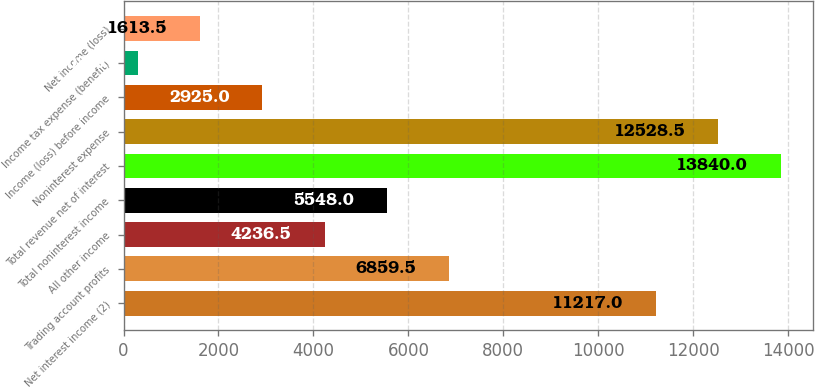Convert chart to OTSL. <chart><loc_0><loc_0><loc_500><loc_500><bar_chart><fcel>Net interest income (2)<fcel>Trading account profits<fcel>All other income<fcel>Total noninterest income<fcel>Total revenue net of interest<fcel>Noninterest expense<fcel>Income (loss) before income<fcel>Income tax expense (benefit)<fcel>Net income (loss)<nl><fcel>11217<fcel>6859.5<fcel>4236.5<fcel>5548<fcel>13840<fcel>12528.5<fcel>2925<fcel>302<fcel>1613.5<nl></chart> 